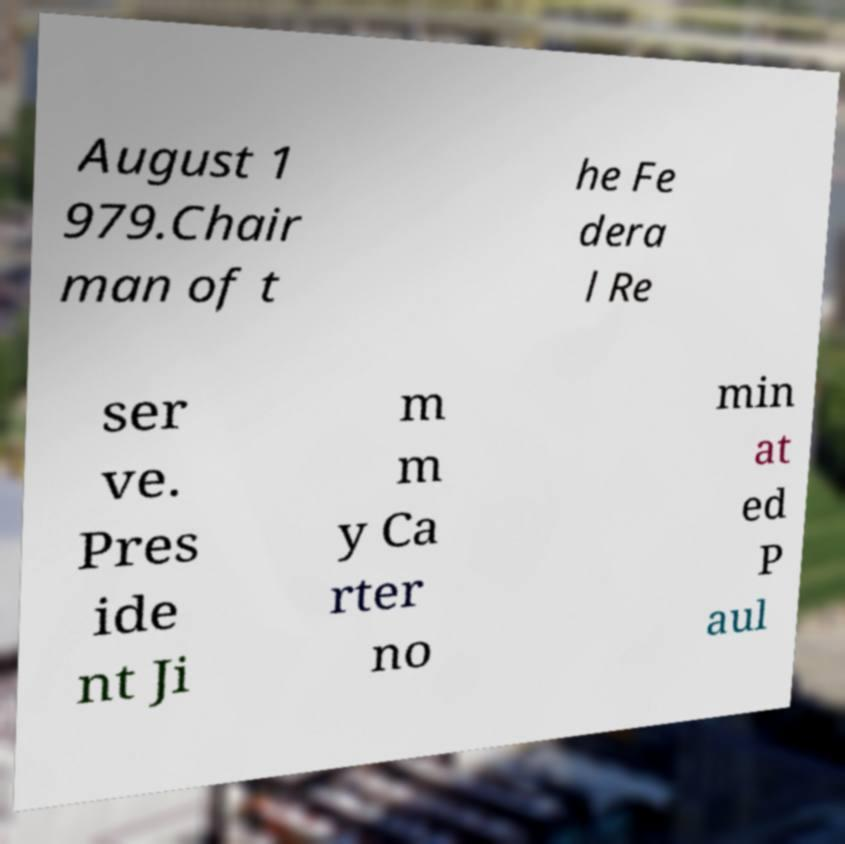Can you read and provide the text displayed in the image?This photo seems to have some interesting text. Can you extract and type it out for me? August 1 979.Chair man of t he Fe dera l Re ser ve. Pres ide nt Ji m m y Ca rter no min at ed P aul 